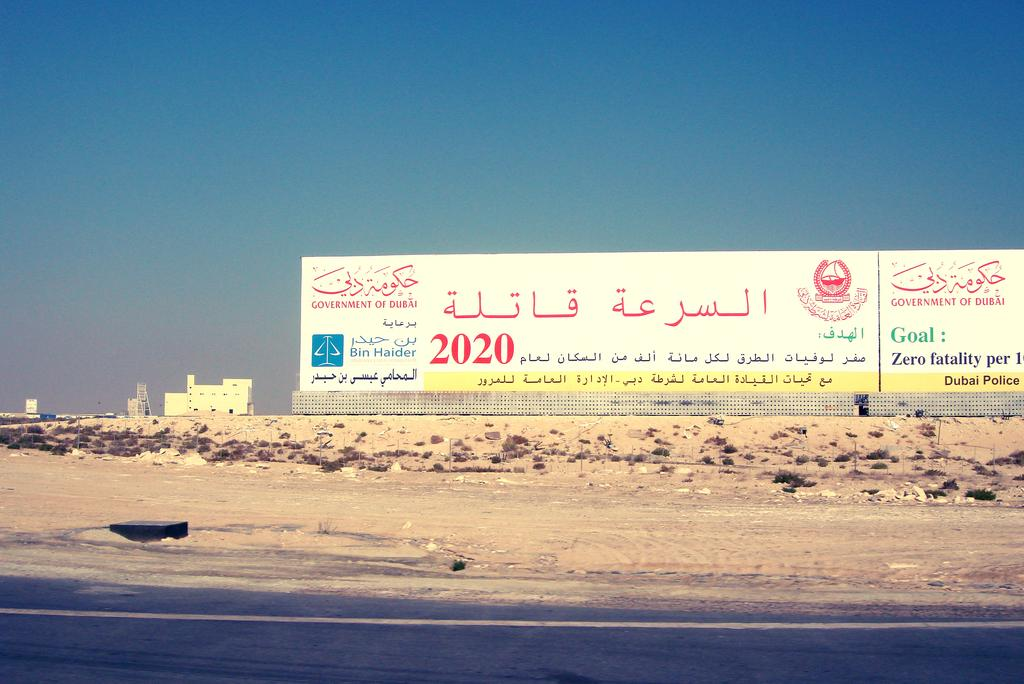<image>
Give a short and clear explanation of the subsequent image. A wall for the Government of Dubai with a Goal of Zero fatality per 1. 